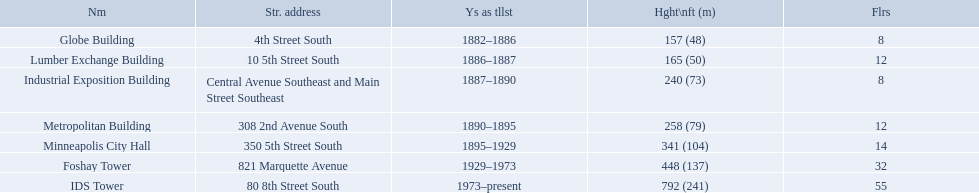What are the heights of the buildings? 157 (48), 165 (50), 240 (73), 258 (79), 341 (104), 448 (137), 792 (241). What building is 240 ft tall? Industrial Exposition Building. What years was 240 ft considered tall? 1887–1890. What building held this record? Industrial Exposition Building. How tall is the metropolitan building? 258 (79). How tall is the lumber exchange building? 165 (50). Is the metropolitan or lumber exchange building taller? Metropolitan Building. Which buildings have the same number of floors as another building? Globe Building, Lumber Exchange Building, Industrial Exposition Building, Metropolitan Building. Of those, which has the same as the lumber exchange building? Metropolitan Building. 